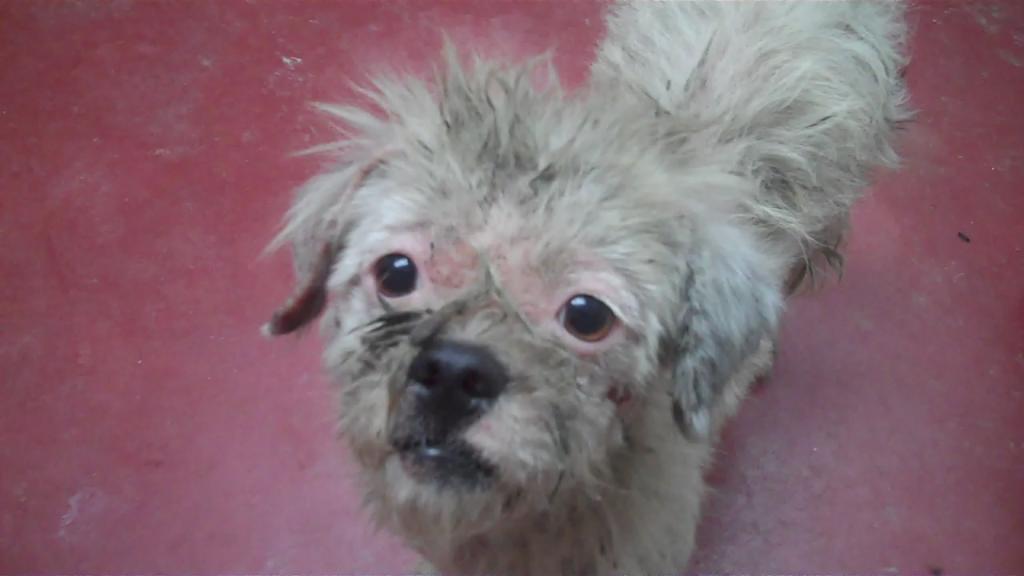In one or two sentences, can you explain what this image depicts? In the center of the image there is a dog. 